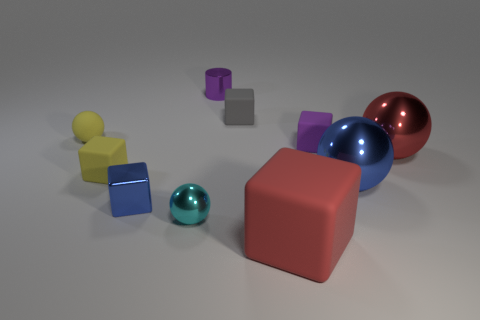Subtract all small yellow rubber cubes. How many cubes are left? 4 Subtract all gray cubes. How many cubes are left? 4 Subtract all green spheres. Subtract all purple cylinders. How many spheres are left? 4 Subtract all balls. How many objects are left? 6 Add 5 small purple metal objects. How many small purple metal objects exist? 6 Subtract 0 blue cylinders. How many objects are left? 10 Subtract all big blue things. Subtract all red things. How many objects are left? 7 Add 4 small yellow rubber balls. How many small yellow rubber balls are left? 5 